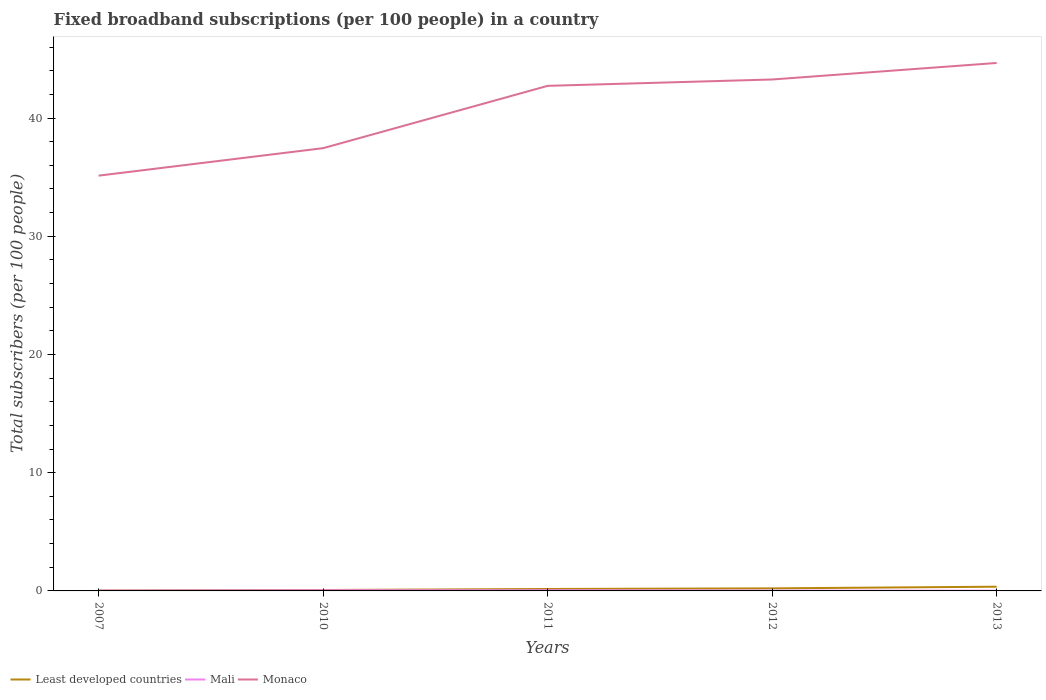How many different coloured lines are there?
Keep it short and to the point. 3. Does the line corresponding to Mali intersect with the line corresponding to Monaco?
Offer a very short reply. No. Is the number of lines equal to the number of legend labels?
Offer a terse response. Yes. Across all years, what is the maximum number of broadband subscriptions in Least developed countries?
Make the answer very short. 0.03. In which year was the number of broadband subscriptions in Least developed countries maximum?
Your answer should be compact. 2007. What is the total number of broadband subscriptions in Least developed countries in the graph?
Ensure brevity in your answer.  -0.13. What is the difference between the highest and the second highest number of broadband subscriptions in Mali?
Your answer should be very brief. 0.04. How many lines are there?
Your answer should be very brief. 3. How many years are there in the graph?
Your answer should be very brief. 5. What is the difference between two consecutive major ticks on the Y-axis?
Offer a very short reply. 10. Does the graph contain any zero values?
Give a very brief answer. No. How are the legend labels stacked?
Your answer should be very brief. Horizontal. What is the title of the graph?
Your answer should be very brief. Fixed broadband subscriptions (per 100 people) in a country. What is the label or title of the X-axis?
Your answer should be compact. Years. What is the label or title of the Y-axis?
Give a very brief answer. Total subscribers (per 100 people). What is the Total subscribers (per 100 people) in Least developed countries in 2007?
Ensure brevity in your answer.  0.03. What is the Total subscribers (per 100 people) in Mali in 2007?
Provide a succinct answer. 0.03. What is the Total subscribers (per 100 people) of Monaco in 2007?
Offer a terse response. 35.13. What is the Total subscribers (per 100 people) in Least developed countries in 2010?
Your answer should be very brief. 0.08. What is the Total subscribers (per 100 people) of Mali in 2010?
Provide a short and direct response. 0.06. What is the Total subscribers (per 100 people) of Monaco in 2010?
Your answer should be very brief. 37.45. What is the Total subscribers (per 100 people) of Least developed countries in 2011?
Offer a very short reply. 0.16. What is the Total subscribers (per 100 people) of Mali in 2011?
Provide a succinct answer. 0.06. What is the Total subscribers (per 100 people) of Monaco in 2011?
Offer a very short reply. 42.73. What is the Total subscribers (per 100 people) of Least developed countries in 2012?
Ensure brevity in your answer.  0.22. What is the Total subscribers (per 100 people) in Mali in 2012?
Provide a short and direct response. 0.03. What is the Total subscribers (per 100 people) in Monaco in 2012?
Your answer should be very brief. 43.26. What is the Total subscribers (per 100 people) in Least developed countries in 2013?
Your answer should be very brief. 0.36. What is the Total subscribers (per 100 people) in Mali in 2013?
Make the answer very short. 0.02. What is the Total subscribers (per 100 people) of Monaco in 2013?
Provide a succinct answer. 44.66. Across all years, what is the maximum Total subscribers (per 100 people) in Least developed countries?
Your response must be concise. 0.36. Across all years, what is the maximum Total subscribers (per 100 people) in Mali?
Your answer should be very brief. 0.06. Across all years, what is the maximum Total subscribers (per 100 people) in Monaco?
Offer a terse response. 44.66. Across all years, what is the minimum Total subscribers (per 100 people) in Least developed countries?
Provide a short and direct response. 0.03. Across all years, what is the minimum Total subscribers (per 100 people) of Mali?
Provide a succinct answer. 0.02. Across all years, what is the minimum Total subscribers (per 100 people) in Monaco?
Your response must be concise. 35.13. What is the total Total subscribers (per 100 people) in Least developed countries in the graph?
Your answer should be very brief. 0.85. What is the total Total subscribers (per 100 people) of Mali in the graph?
Your response must be concise. 0.19. What is the total Total subscribers (per 100 people) in Monaco in the graph?
Ensure brevity in your answer.  203.24. What is the difference between the Total subscribers (per 100 people) in Least developed countries in 2007 and that in 2010?
Ensure brevity in your answer.  -0.04. What is the difference between the Total subscribers (per 100 people) in Mali in 2007 and that in 2010?
Offer a terse response. -0.03. What is the difference between the Total subscribers (per 100 people) of Monaco in 2007 and that in 2010?
Your answer should be compact. -2.32. What is the difference between the Total subscribers (per 100 people) in Least developed countries in 2007 and that in 2011?
Provide a succinct answer. -0.13. What is the difference between the Total subscribers (per 100 people) of Mali in 2007 and that in 2011?
Offer a very short reply. -0.03. What is the difference between the Total subscribers (per 100 people) of Monaco in 2007 and that in 2011?
Offer a terse response. -7.6. What is the difference between the Total subscribers (per 100 people) in Least developed countries in 2007 and that in 2012?
Offer a terse response. -0.18. What is the difference between the Total subscribers (per 100 people) in Mali in 2007 and that in 2012?
Keep it short and to the point. -0. What is the difference between the Total subscribers (per 100 people) of Monaco in 2007 and that in 2012?
Your response must be concise. -8.13. What is the difference between the Total subscribers (per 100 people) in Least developed countries in 2007 and that in 2013?
Give a very brief answer. -0.32. What is the difference between the Total subscribers (per 100 people) in Mali in 2007 and that in 2013?
Keep it short and to the point. 0.01. What is the difference between the Total subscribers (per 100 people) of Monaco in 2007 and that in 2013?
Provide a succinct answer. -9.53. What is the difference between the Total subscribers (per 100 people) of Least developed countries in 2010 and that in 2011?
Provide a succinct answer. -0.09. What is the difference between the Total subscribers (per 100 people) in Mali in 2010 and that in 2011?
Your answer should be very brief. -0. What is the difference between the Total subscribers (per 100 people) of Monaco in 2010 and that in 2011?
Your answer should be compact. -5.27. What is the difference between the Total subscribers (per 100 people) of Least developed countries in 2010 and that in 2012?
Keep it short and to the point. -0.14. What is the difference between the Total subscribers (per 100 people) of Mali in 2010 and that in 2012?
Give a very brief answer. 0.03. What is the difference between the Total subscribers (per 100 people) in Monaco in 2010 and that in 2012?
Offer a terse response. -5.81. What is the difference between the Total subscribers (per 100 people) of Least developed countries in 2010 and that in 2013?
Offer a very short reply. -0.28. What is the difference between the Total subscribers (per 100 people) of Mali in 2010 and that in 2013?
Give a very brief answer. 0.04. What is the difference between the Total subscribers (per 100 people) of Monaco in 2010 and that in 2013?
Your answer should be very brief. -7.21. What is the difference between the Total subscribers (per 100 people) in Least developed countries in 2011 and that in 2012?
Make the answer very short. -0.05. What is the difference between the Total subscribers (per 100 people) in Mali in 2011 and that in 2012?
Your answer should be compact. 0.03. What is the difference between the Total subscribers (per 100 people) of Monaco in 2011 and that in 2012?
Provide a short and direct response. -0.54. What is the difference between the Total subscribers (per 100 people) in Least developed countries in 2011 and that in 2013?
Your answer should be compact. -0.19. What is the difference between the Total subscribers (per 100 people) in Mali in 2011 and that in 2013?
Offer a terse response. 0.04. What is the difference between the Total subscribers (per 100 people) in Monaco in 2011 and that in 2013?
Your answer should be compact. -1.94. What is the difference between the Total subscribers (per 100 people) in Least developed countries in 2012 and that in 2013?
Make the answer very short. -0.14. What is the difference between the Total subscribers (per 100 people) in Mali in 2012 and that in 2013?
Make the answer very short. 0.01. What is the difference between the Total subscribers (per 100 people) of Monaco in 2012 and that in 2013?
Your answer should be very brief. -1.4. What is the difference between the Total subscribers (per 100 people) in Least developed countries in 2007 and the Total subscribers (per 100 people) in Mali in 2010?
Offer a terse response. -0.02. What is the difference between the Total subscribers (per 100 people) in Least developed countries in 2007 and the Total subscribers (per 100 people) in Monaco in 2010?
Make the answer very short. -37.42. What is the difference between the Total subscribers (per 100 people) of Mali in 2007 and the Total subscribers (per 100 people) of Monaco in 2010?
Your answer should be very brief. -37.43. What is the difference between the Total subscribers (per 100 people) in Least developed countries in 2007 and the Total subscribers (per 100 people) in Mali in 2011?
Keep it short and to the point. -0.03. What is the difference between the Total subscribers (per 100 people) in Least developed countries in 2007 and the Total subscribers (per 100 people) in Monaco in 2011?
Offer a very short reply. -42.69. What is the difference between the Total subscribers (per 100 people) of Mali in 2007 and the Total subscribers (per 100 people) of Monaco in 2011?
Provide a succinct answer. -42.7. What is the difference between the Total subscribers (per 100 people) in Least developed countries in 2007 and the Total subscribers (per 100 people) in Mali in 2012?
Your answer should be very brief. 0. What is the difference between the Total subscribers (per 100 people) of Least developed countries in 2007 and the Total subscribers (per 100 people) of Monaco in 2012?
Provide a succinct answer. -43.23. What is the difference between the Total subscribers (per 100 people) of Mali in 2007 and the Total subscribers (per 100 people) of Monaco in 2012?
Ensure brevity in your answer.  -43.24. What is the difference between the Total subscribers (per 100 people) of Least developed countries in 2007 and the Total subscribers (per 100 people) of Mali in 2013?
Give a very brief answer. 0.01. What is the difference between the Total subscribers (per 100 people) of Least developed countries in 2007 and the Total subscribers (per 100 people) of Monaco in 2013?
Your response must be concise. -44.63. What is the difference between the Total subscribers (per 100 people) in Mali in 2007 and the Total subscribers (per 100 people) in Monaco in 2013?
Your response must be concise. -44.64. What is the difference between the Total subscribers (per 100 people) of Least developed countries in 2010 and the Total subscribers (per 100 people) of Mali in 2011?
Give a very brief answer. 0.02. What is the difference between the Total subscribers (per 100 people) of Least developed countries in 2010 and the Total subscribers (per 100 people) of Monaco in 2011?
Keep it short and to the point. -42.65. What is the difference between the Total subscribers (per 100 people) of Mali in 2010 and the Total subscribers (per 100 people) of Monaco in 2011?
Give a very brief answer. -42.67. What is the difference between the Total subscribers (per 100 people) of Least developed countries in 2010 and the Total subscribers (per 100 people) of Mali in 2012?
Your answer should be very brief. 0.05. What is the difference between the Total subscribers (per 100 people) in Least developed countries in 2010 and the Total subscribers (per 100 people) in Monaco in 2012?
Keep it short and to the point. -43.19. What is the difference between the Total subscribers (per 100 people) of Mali in 2010 and the Total subscribers (per 100 people) of Monaco in 2012?
Keep it short and to the point. -43.21. What is the difference between the Total subscribers (per 100 people) of Least developed countries in 2010 and the Total subscribers (per 100 people) of Mali in 2013?
Give a very brief answer. 0.06. What is the difference between the Total subscribers (per 100 people) of Least developed countries in 2010 and the Total subscribers (per 100 people) of Monaco in 2013?
Provide a short and direct response. -44.58. What is the difference between the Total subscribers (per 100 people) of Mali in 2010 and the Total subscribers (per 100 people) of Monaco in 2013?
Ensure brevity in your answer.  -44.6. What is the difference between the Total subscribers (per 100 people) in Least developed countries in 2011 and the Total subscribers (per 100 people) in Mali in 2012?
Provide a short and direct response. 0.13. What is the difference between the Total subscribers (per 100 people) of Least developed countries in 2011 and the Total subscribers (per 100 people) of Monaco in 2012?
Your answer should be very brief. -43.1. What is the difference between the Total subscribers (per 100 people) of Mali in 2011 and the Total subscribers (per 100 people) of Monaco in 2012?
Your answer should be compact. -43.2. What is the difference between the Total subscribers (per 100 people) in Least developed countries in 2011 and the Total subscribers (per 100 people) in Mali in 2013?
Your response must be concise. 0.14. What is the difference between the Total subscribers (per 100 people) of Least developed countries in 2011 and the Total subscribers (per 100 people) of Monaco in 2013?
Give a very brief answer. -44.5. What is the difference between the Total subscribers (per 100 people) in Mali in 2011 and the Total subscribers (per 100 people) in Monaco in 2013?
Your answer should be very brief. -44.6. What is the difference between the Total subscribers (per 100 people) of Least developed countries in 2012 and the Total subscribers (per 100 people) of Mali in 2013?
Your answer should be compact. 0.2. What is the difference between the Total subscribers (per 100 people) in Least developed countries in 2012 and the Total subscribers (per 100 people) in Monaco in 2013?
Make the answer very short. -44.44. What is the difference between the Total subscribers (per 100 people) in Mali in 2012 and the Total subscribers (per 100 people) in Monaco in 2013?
Give a very brief answer. -44.63. What is the average Total subscribers (per 100 people) in Least developed countries per year?
Make the answer very short. 0.17. What is the average Total subscribers (per 100 people) in Mali per year?
Offer a terse response. 0.04. What is the average Total subscribers (per 100 people) of Monaco per year?
Offer a very short reply. 40.65. In the year 2007, what is the difference between the Total subscribers (per 100 people) in Least developed countries and Total subscribers (per 100 people) in Mali?
Give a very brief answer. 0.01. In the year 2007, what is the difference between the Total subscribers (per 100 people) of Least developed countries and Total subscribers (per 100 people) of Monaco?
Ensure brevity in your answer.  -35.1. In the year 2007, what is the difference between the Total subscribers (per 100 people) in Mali and Total subscribers (per 100 people) in Monaco?
Your answer should be very brief. -35.1. In the year 2010, what is the difference between the Total subscribers (per 100 people) in Least developed countries and Total subscribers (per 100 people) in Mali?
Your answer should be compact. 0.02. In the year 2010, what is the difference between the Total subscribers (per 100 people) of Least developed countries and Total subscribers (per 100 people) of Monaco?
Make the answer very short. -37.38. In the year 2010, what is the difference between the Total subscribers (per 100 people) of Mali and Total subscribers (per 100 people) of Monaco?
Your answer should be very brief. -37.4. In the year 2011, what is the difference between the Total subscribers (per 100 people) in Least developed countries and Total subscribers (per 100 people) in Mali?
Your answer should be compact. 0.11. In the year 2011, what is the difference between the Total subscribers (per 100 people) of Least developed countries and Total subscribers (per 100 people) of Monaco?
Your response must be concise. -42.56. In the year 2011, what is the difference between the Total subscribers (per 100 people) of Mali and Total subscribers (per 100 people) of Monaco?
Your answer should be very brief. -42.67. In the year 2012, what is the difference between the Total subscribers (per 100 people) of Least developed countries and Total subscribers (per 100 people) of Mali?
Your answer should be compact. 0.19. In the year 2012, what is the difference between the Total subscribers (per 100 people) in Least developed countries and Total subscribers (per 100 people) in Monaco?
Offer a very short reply. -43.05. In the year 2012, what is the difference between the Total subscribers (per 100 people) of Mali and Total subscribers (per 100 people) of Monaco?
Keep it short and to the point. -43.23. In the year 2013, what is the difference between the Total subscribers (per 100 people) in Least developed countries and Total subscribers (per 100 people) in Mali?
Your answer should be compact. 0.34. In the year 2013, what is the difference between the Total subscribers (per 100 people) of Least developed countries and Total subscribers (per 100 people) of Monaco?
Make the answer very short. -44.3. In the year 2013, what is the difference between the Total subscribers (per 100 people) in Mali and Total subscribers (per 100 people) in Monaco?
Your response must be concise. -44.64. What is the ratio of the Total subscribers (per 100 people) in Least developed countries in 2007 to that in 2010?
Give a very brief answer. 0.43. What is the ratio of the Total subscribers (per 100 people) in Mali in 2007 to that in 2010?
Offer a very short reply. 0.44. What is the ratio of the Total subscribers (per 100 people) of Monaco in 2007 to that in 2010?
Your answer should be very brief. 0.94. What is the ratio of the Total subscribers (per 100 people) of Least developed countries in 2007 to that in 2011?
Your answer should be very brief. 0.2. What is the ratio of the Total subscribers (per 100 people) in Mali in 2007 to that in 2011?
Ensure brevity in your answer.  0.43. What is the ratio of the Total subscribers (per 100 people) in Monaco in 2007 to that in 2011?
Your response must be concise. 0.82. What is the ratio of the Total subscribers (per 100 people) of Least developed countries in 2007 to that in 2012?
Your response must be concise. 0.15. What is the ratio of the Total subscribers (per 100 people) in Mali in 2007 to that in 2012?
Keep it short and to the point. 0.86. What is the ratio of the Total subscribers (per 100 people) in Monaco in 2007 to that in 2012?
Offer a terse response. 0.81. What is the ratio of the Total subscribers (per 100 people) in Least developed countries in 2007 to that in 2013?
Your answer should be very brief. 0.09. What is the ratio of the Total subscribers (per 100 people) of Mali in 2007 to that in 2013?
Offer a terse response. 1.32. What is the ratio of the Total subscribers (per 100 people) of Monaco in 2007 to that in 2013?
Make the answer very short. 0.79. What is the ratio of the Total subscribers (per 100 people) of Least developed countries in 2010 to that in 2011?
Your response must be concise. 0.47. What is the ratio of the Total subscribers (per 100 people) in Mali in 2010 to that in 2011?
Offer a terse response. 0.97. What is the ratio of the Total subscribers (per 100 people) in Monaco in 2010 to that in 2011?
Offer a very short reply. 0.88. What is the ratio of the Total subscribers (per 100 people) of Least developed countries in 2010 to that in 2012?
Your answer should be very brief. 0.36. What is the ratio of the Total subscribers (per 100 people) in Mali in 2010 to that in 2012?
Keep it short and to the point. 1.97. What is the ratio of the Total subscribers (per 100 people) in Monaco in 2010 to that in 2012?
Give a very brief answer. 0.87. What is the ratio of the Total subscribers (per 100 people) in Least developed countries in 2010 to that in 2013?
Your answer should be very brief. 0.22. What is the ratio of the Total subscribers (per 100 people) of Mali in 2010 to that in 2013?
Your response must be concise. 3.02. What is the ratio of the Total subscribers (per 100 people) in Monaco in 2010 to that in 2013?
Your response must be concise. 0.84. What is the ratio of the Total subscribers (per 100 people) of Least developed countries in 2011 to that in 2012?
Your response must be concise. 0.76. What is the ratio of the Total subscribers (per 100 people) of Mali in 2011 to that in 2012?
Offer a terse response. 2.02. What is the ratio of the Total subscribers (per 100 people) of Monaco in 2011 to that in 2012?
Keep it short and to the point. 0.99. What is the ratio of the Total subscribers (per 100 people) in Least developed countries in 2011 to that in 2013?
Make the answer very short. 0.46. What is the ratio of the Total subscribers (per 100 people) of Mali in 2011 to that in 2013?
Keep it short and to the point. 3.09. What is the ratio of the Total subscribers (per 100 people) of Monaco in 2011 to that in 2013?
Keep it short and to the point. 0.96. What is the ratio of the Total subscribers (per 100 people) of Least developed countries in 2012 to that in 2013?
Give a very brief answer. 0.61. What is the ratio of the Total subscribers (per 100 people) of Mali in 2012 to that in 2013?
Your response must be concise. 1.53. What is the ratio of the Total subscribers (per 100 people) of Monaco in 2012 to that in 2013?
Offer a terse response. 0.97. What is the difference between the highest and the second highest Total subscribers (per 100 people) of Least developed countries?
Offer a terse response. 0.14. What is the difference between the highest and the second highest Total subscribers (per 100 people) of Mali?
Provide a succinct answer. 0. What is the difference between the highest and the second highest Total subscribers (per 100 people) in Monaco?
Provide a succinct answer. 1.4. What is the difference between the highest and the lowest Total subscribers (per 100 people) in Least developed countries?
Ensure brevity in your answer.  0.32. What is the difference between the highest and the lowest Total subscribers (per 100 people) of Mali?
Your answer should be compact. 0.04. What is the difference between the highest and the lowest Total subscribers (per 100 people) of Monaco?
Provide a succinct answer. 9.53. 